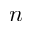<formula> <loc_0><loc_0><loc_500><loc_500>n</formula> 